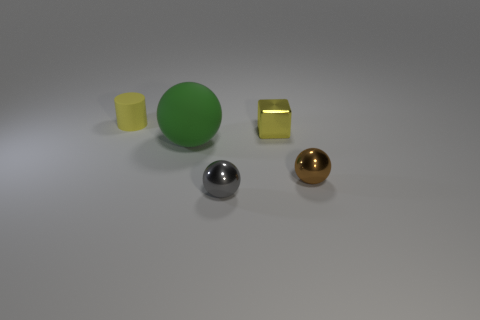Add 5 tiny green cylinders. How many objects exist? 10 Subtract all cubes. How many objects are left? 4 Subtract 0 green cubes. How many objects are left? 5 Subtract all yellow rubber objects. Subtract all purple matte cylinders. How many objects are left? 4 Add 2 brown things. How many brown things are left? 3 Add 1 green cylinders. How many green cylinders exist? 1 